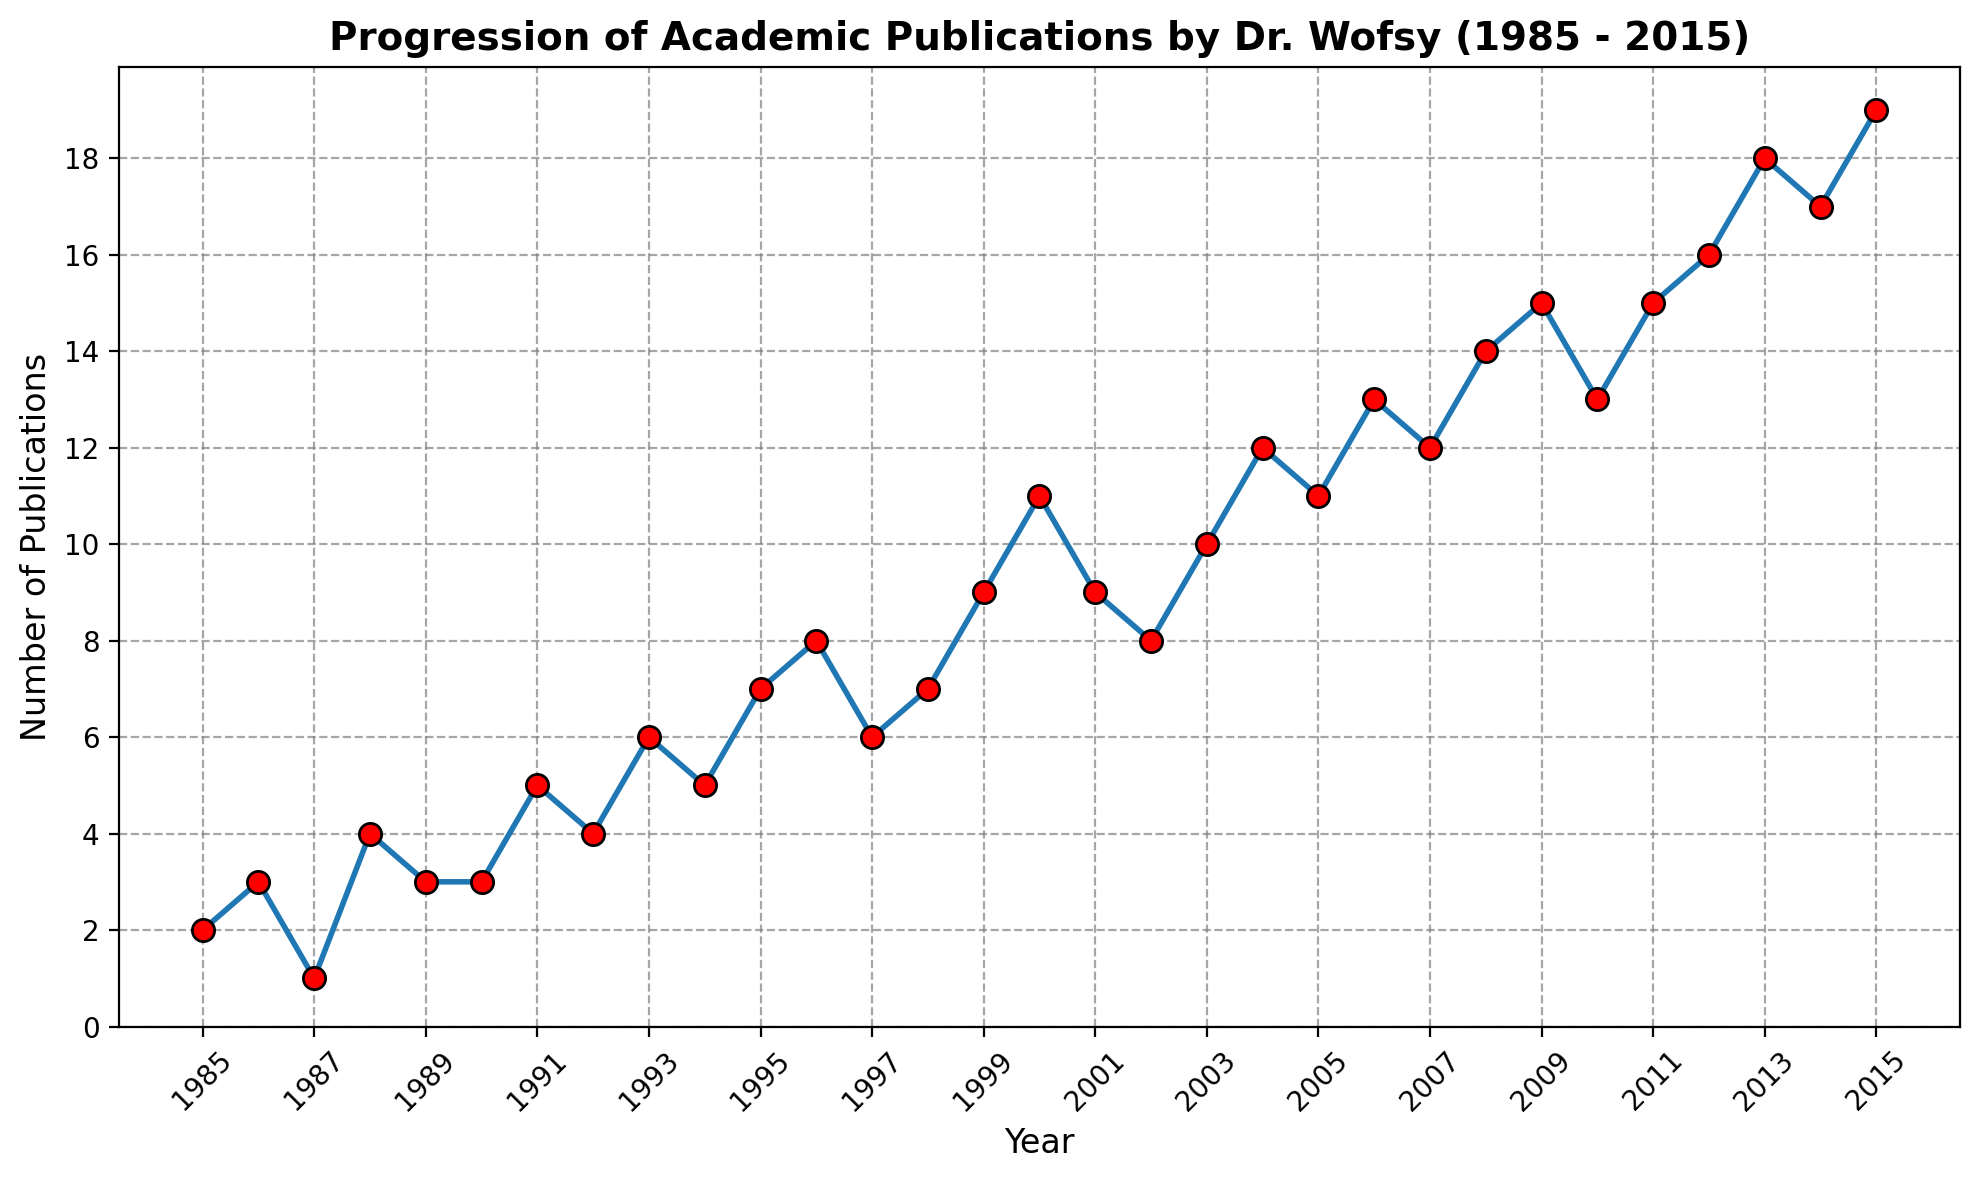What's the total number of publications from 1985 to 1990? Sum the publications from the years 1985, 1986, 1987, 1988, 1989, and 1990. The result is 2 + 3 + 1 + 4 + 3 + 3 = 16.
Answer: 16 Which year had the highest number of publications? By looking at the peak of the line plot, the highest number of publications is 19 in 2015.
Answer: 2015 What's the average number of publications per year between 2005 and 2010? Sum the publications for each year from 2005 to 2010 and divide by the number of years. The sum is 11 + 13 + 12 + 14 + 15 + 13 = 78. Divide by 6 years to get the average: 78 / 6 = 13.
Answer: 13 Did the number of publications ever decrease from one year to the next between 2000 and 2015? Compare the publication numbers year by year from 2000 to 2015. Yes, it decreased from 2000 to 2001 (11 to 9), from 2003 to 2004 (10 to 12), and from 2009 to 2010 (15 to 13).
Answer: Yes Compared to 1985, how many more publications were there in 2015? Subtract the number of publications in 1985 from the publications in 2015. The result is 19 (2015) - 2 (1985) = 17.
Answer: 17 What's the difference in the number of publications between 2008 and 2013? By subtracting the number of publications in 2008 from that in 2013, we get 18 (2013) - 14 (2008) = 4.
Answer: 4 Which year marked exactly double the number of publications compared to 1987? The number of publications in 1987 was 1; look for a year with 2 publications. However, 1986 is close with 3, but none of the years had exactly 2 publications. So none is the answer.
Answer: None Did the number of publications consistently increase from 2002 to 2006? Check the number of publications for each year from 2002 to 2006. 2002 had 8, 2003 had 10, 2004 had 12, 2005 had 11, and 2006 had 13. Between 2004 and 2005, the number decreased, so the increase was not consistent.
Answer: No What's the median number of publications over the entire period from 1985 to 2015? List all the publication numbers in order and find the middle value. The sorted publication numbers are [1, 2, 3, 3, 3, 4, 4, 5, 5, 6, 6, 7, 7, 8, 8, 9, 9, 10, 11, 11, 12, 12, 13, 13, 14, 15, 15, 16, 17, 18, 19]. The median (middle value) in this list of 31 numbers is 9.
Answer: 9 